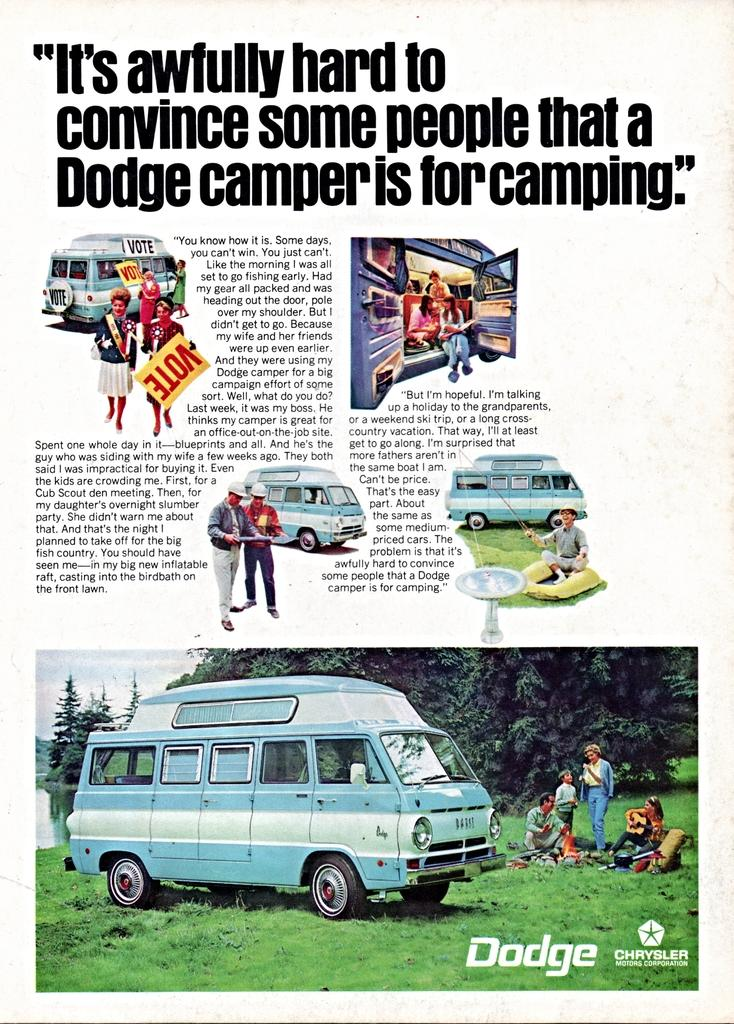What type of vehicles are present in the image? There are trucks in the image. Who or what else can be seen in the image? There are persons and boards visible in the image. What type of natural environment is present in the image? There are trees and grass in the image. Is there any text present in the image? Yes, there is text in the image. How can we describe the noise level in the image? The noise level cannot be determined from the image, as there is no information about sounds or volume. 